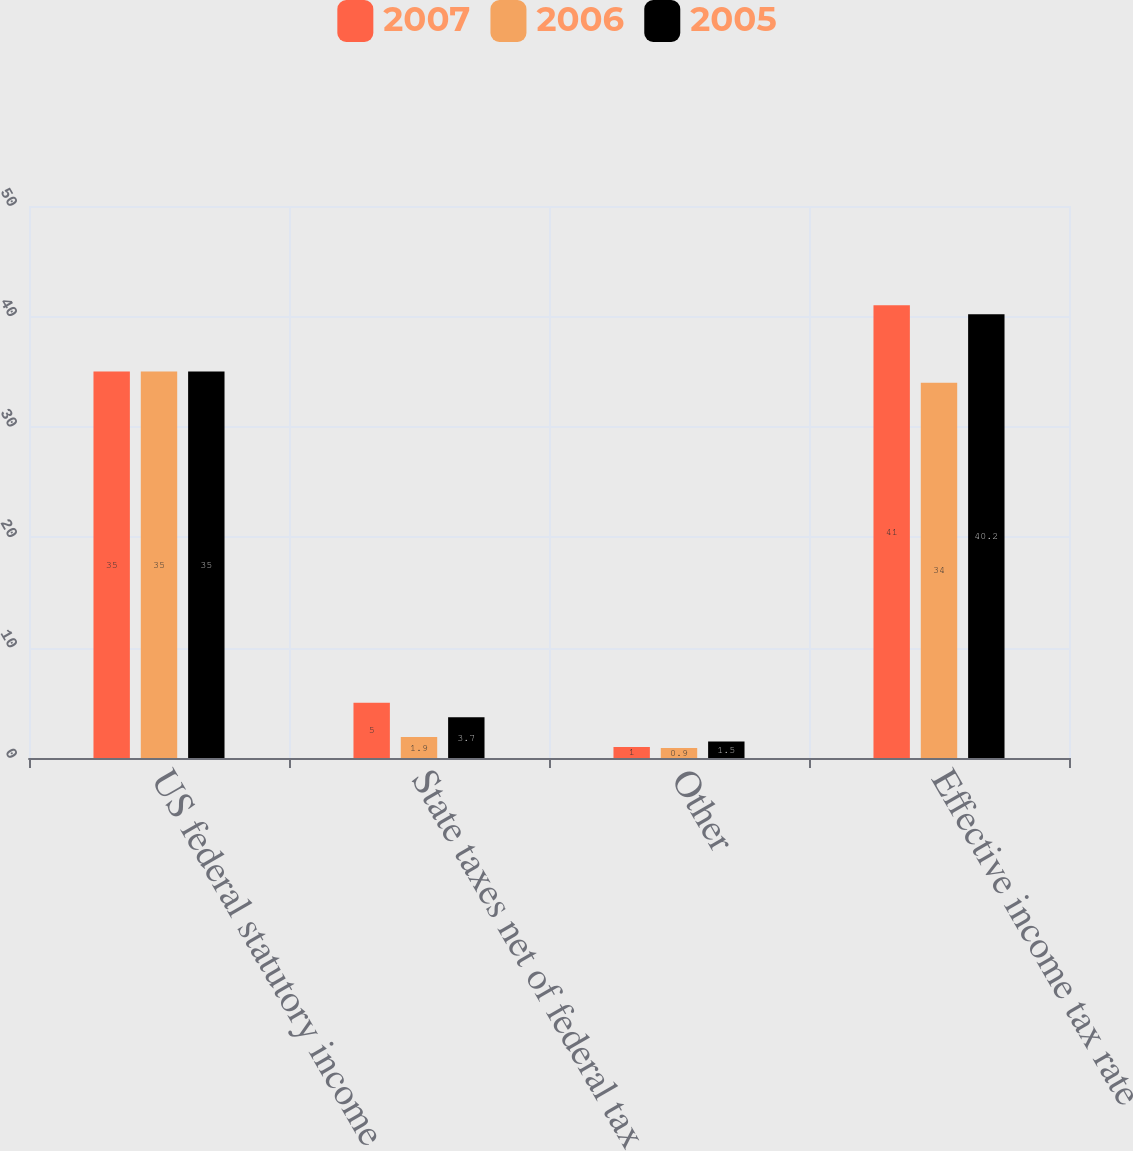Convert chart to OTSL. <chart><loc_0><loc_0><loc_500><loc_500><stacked_bar_chart><ecel><fcel>US federal statutory income<fcel>State taxes net of federal tax<fcel>Other<fcel>Effective income tax rate<nl><fcel>2007<fcel>35<fcel>5<fcel>1<fcel>41<nl><fcel>2006<fcel>35<fcel>1.9<fcel>0.9<fcel>34<nl><fcel>2005<fcel>35<fcel>3.7<fcel>1.5<fcel>40.2<nl></chart> 